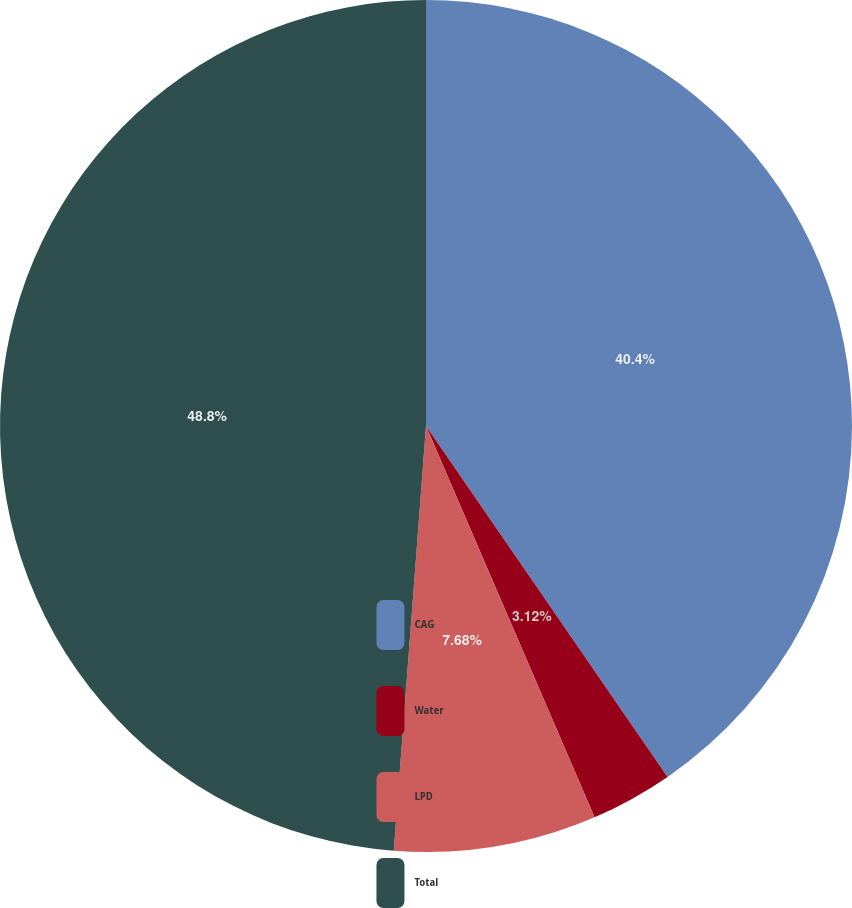Convert chart to OTSL. <chart><loc_0><loc_0><loc_500><loc_500><pie_chart><fcel>CAG<fcel>Water<fcel>LPD<fcel>Total<nl><fcel>40.4%<fcel>3.12%<fcel>7.68%<fcel>48.79%<nl></chart> 